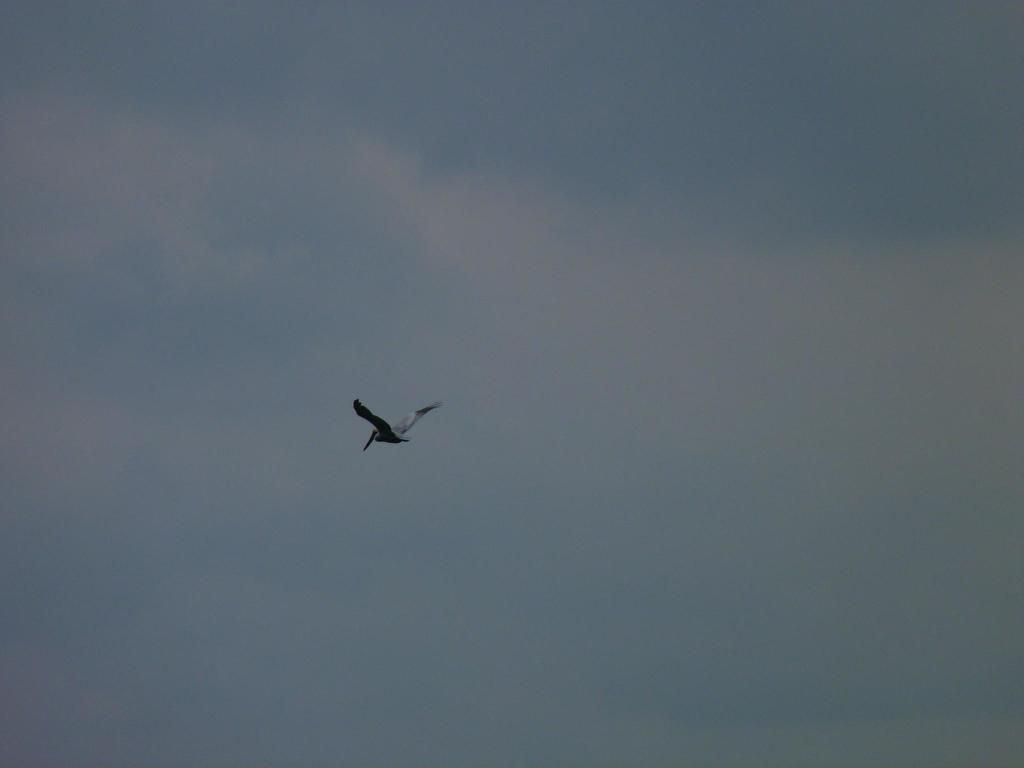What type of animal can be seen in the image? There is a bird in the image. What is the bird doing in the image? The bird is flying in the air. What can be seen in the background of the image? The sky is visible in the background of the image. Where is the library located in the image? There is no library present in the image. Can you see the bird's arm in the image? Birds do not have arms; they have wings. The image only shows the bird flying with its wings. 